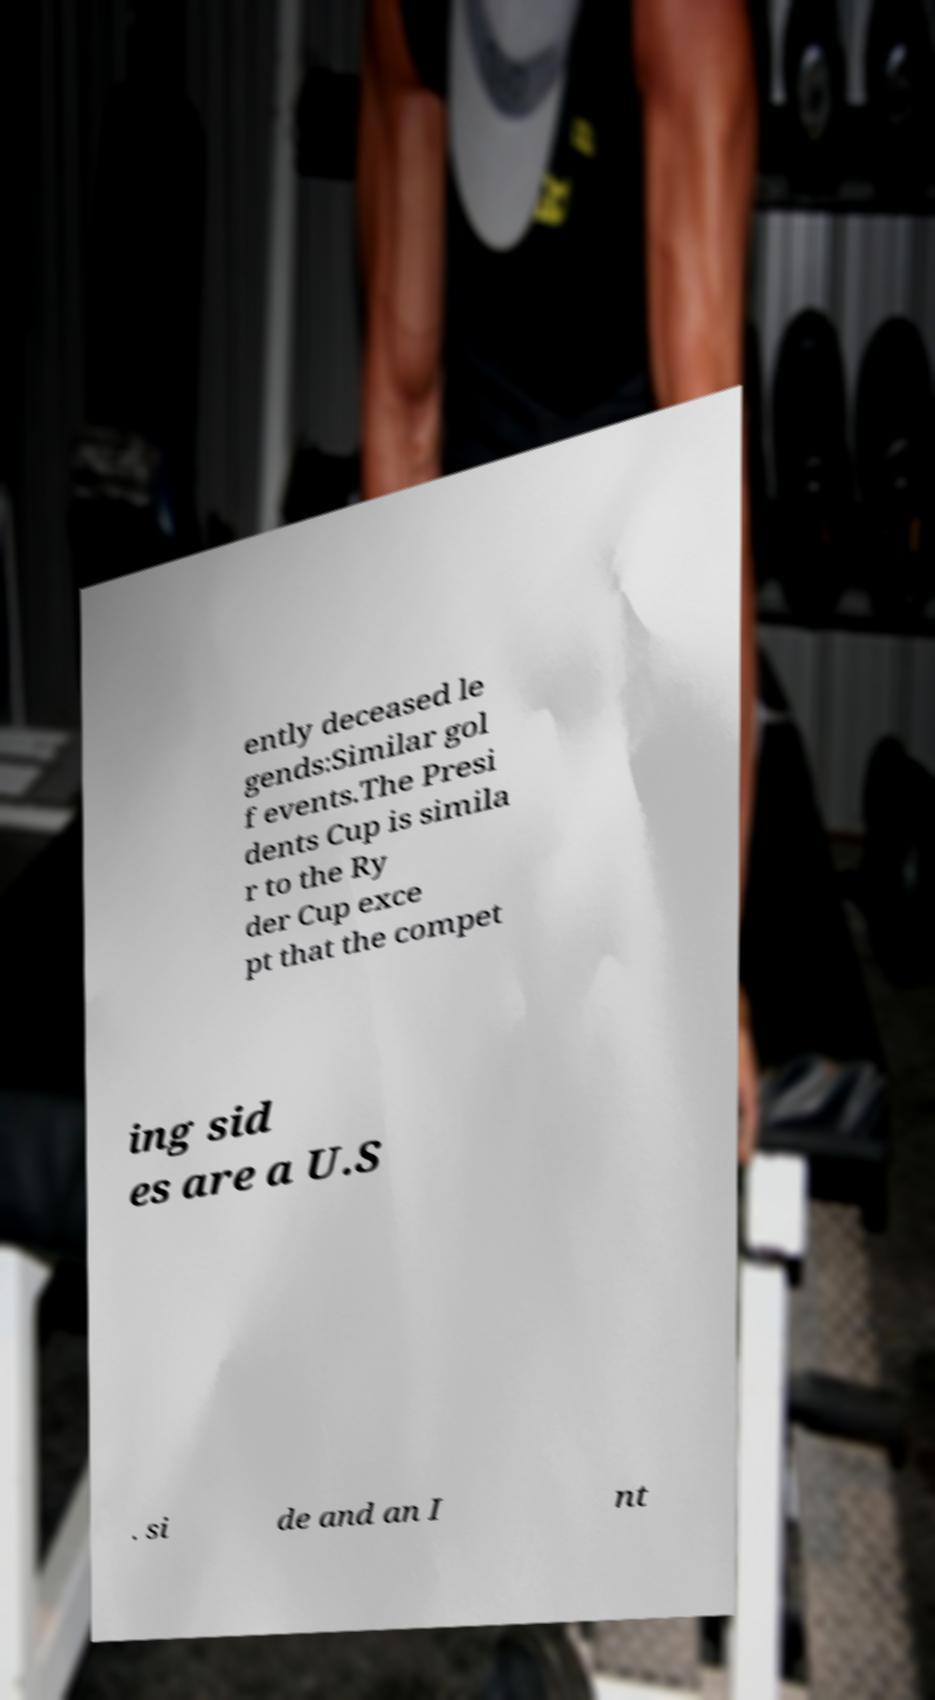Please read and relay the text visible in this image. What does it say? ently deceased le gends:Similar gol f events.The Presi dents Cup is simila r to the Ry der Cup exce pt that the compet ing sid es are a U.S . si de and an I nt 